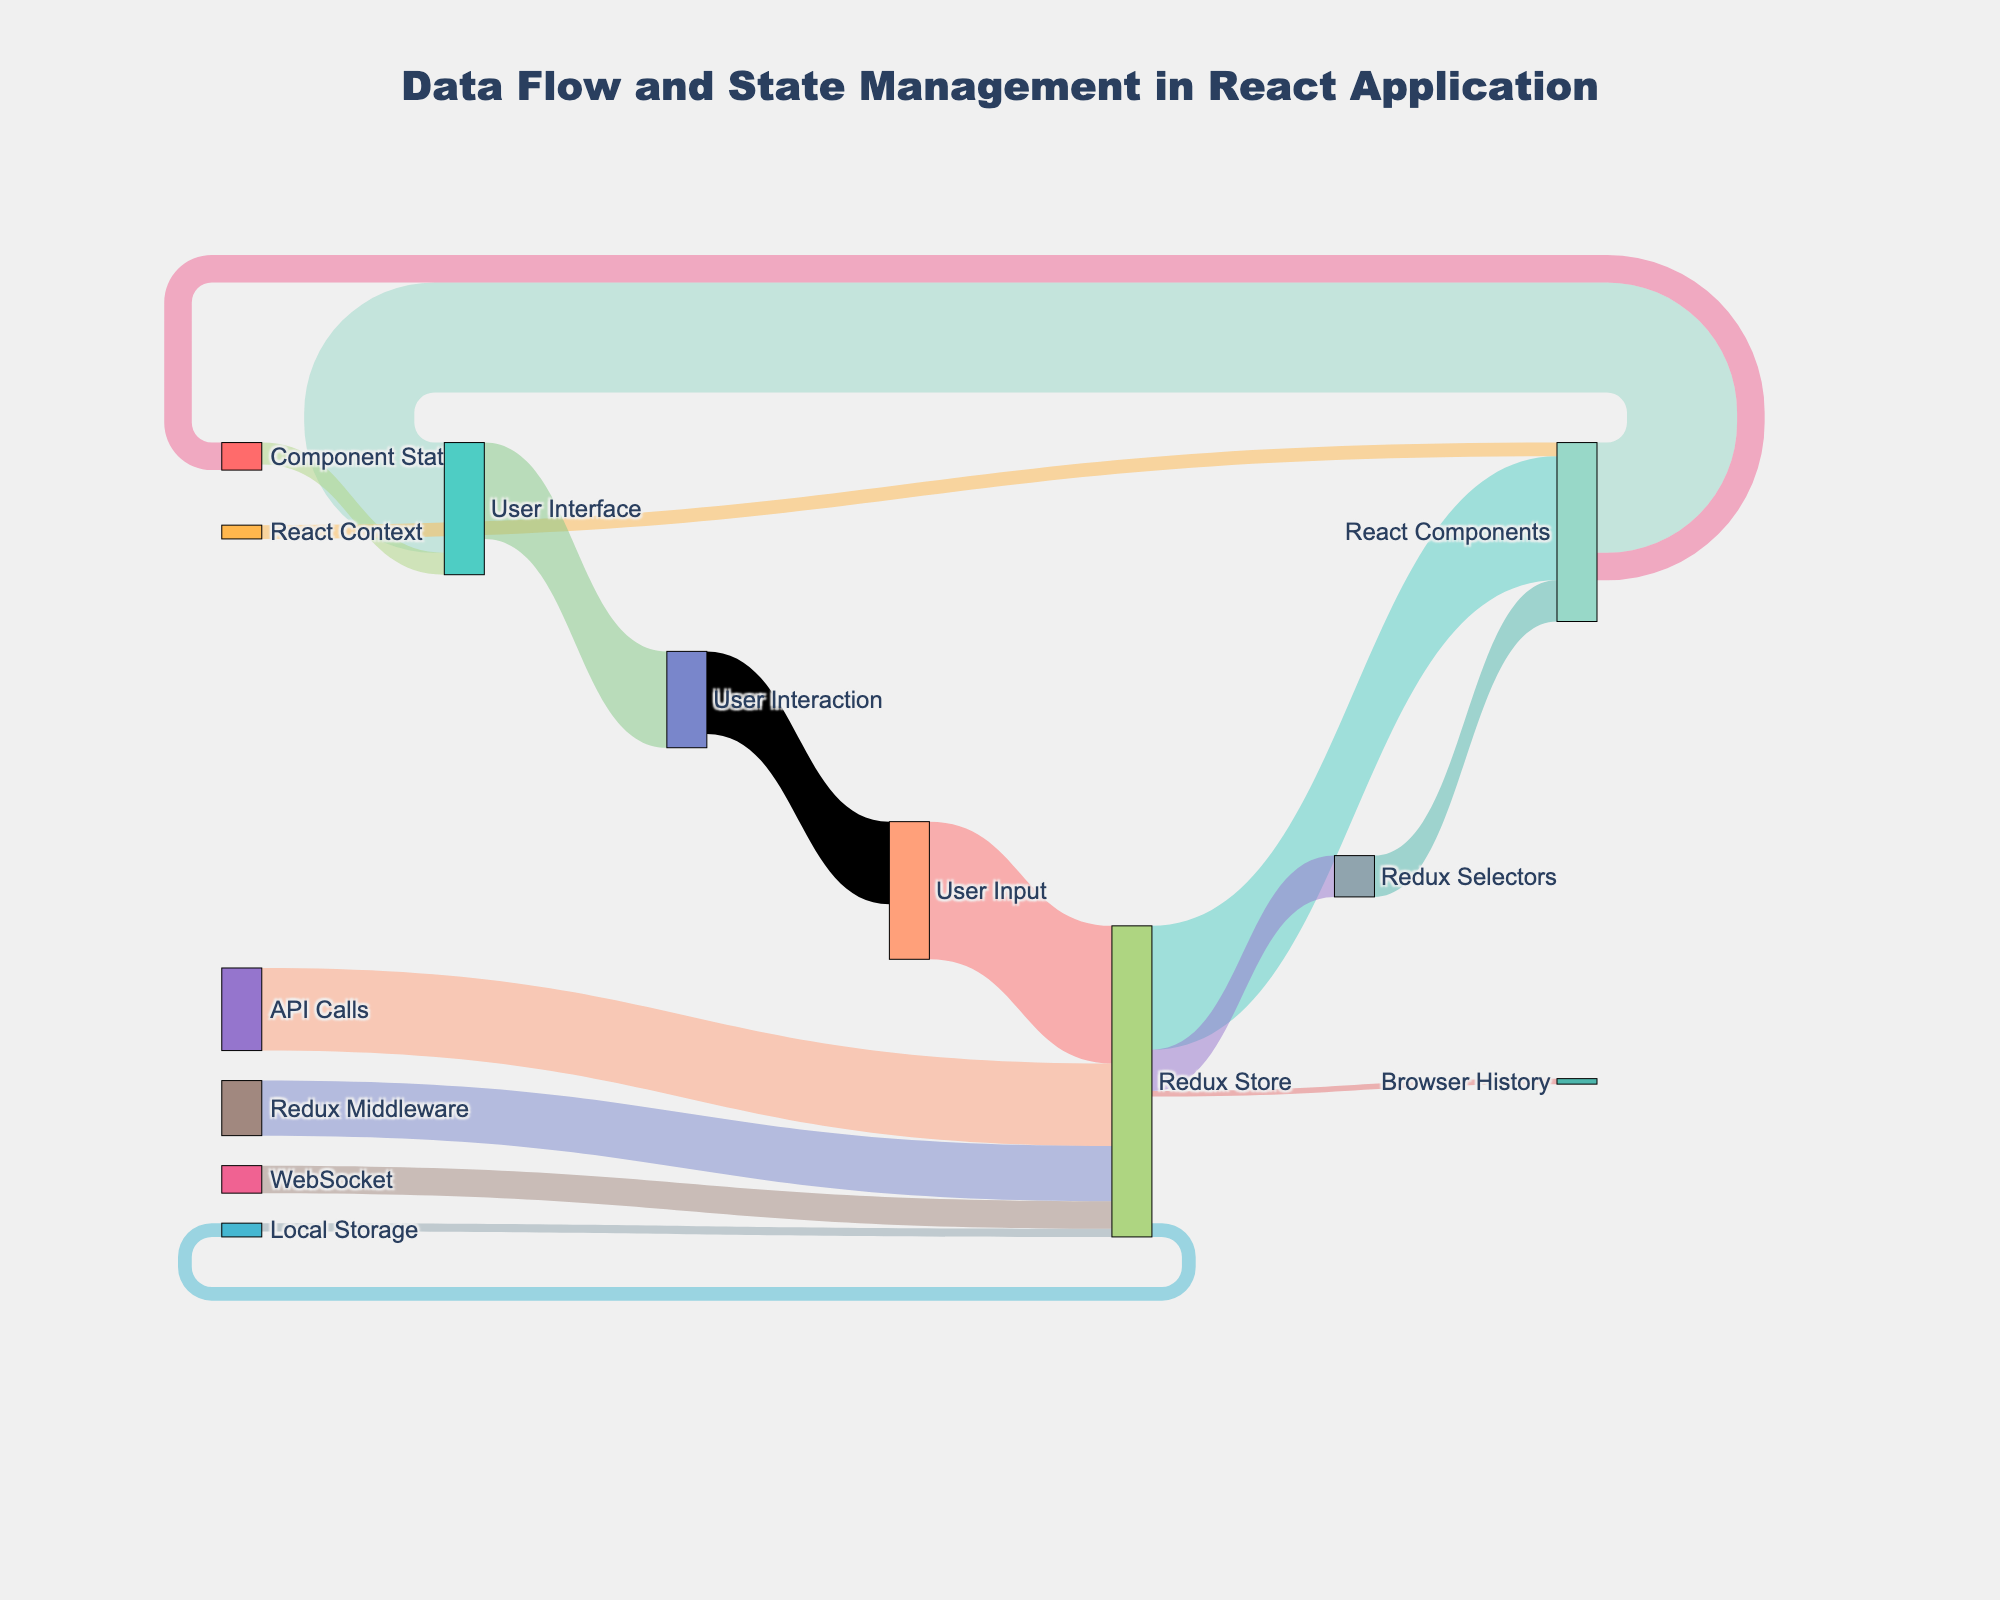What is the title of the diagram? The title is displayed at the top of the diagram and gives an overview of what the Sankey diagram represents.
Answer: Data Flow and State Management in React Application Which source node has the highest value flowing into the Redux Store? Look at all the connections flowing into the Redux Store. Identify the connection with the highest value.
Answer: User Input What is the combined value of data flowing from the Redux Store to other nodes? Sum up all the values flowing out from the Redux Store to other nodes: 45 (React Components) + 5 (Local Storage) + 15 (Redux Selectors) + 2 (Browser History).
Answer: 67 Which two components have direct data flow between them with the highest value, and what is that value? Identify the pair of components connected directly with the highest value by examining the diagram.
Answer: User Input and Redux Store How many unique nodes are there in the Sankey diagram? Count all the unique labels in the nodes section of the diagram.
Answer: 14 What is the value of data flowing between React Components and User Interface? Find the link between React Components and User Interface and note its value.
Answer: 40 What is the sum of values flowing into the User Interface? Add the values flowing into the User Interface: 40 (React Components) + 8 (Component State).
Answer: 48 Which has a higher value, data going from React Components to Component State or data going from Component State to User Interface? Compare the values of these two connections and determine the higher value.
Answer: React Components to Component State What is the total value of data flowing from any source to the Redux Store? Sum all the values flowing into the Redux Store: 50 (User Input) + 30 (API Calls) + 20 (Redux Middleware) + 10 (WebSocket) + 3 (Local Storage).
Answer: 113 How much data flows from User Interaction back to User Input? Look at the link from User Interaction to User Input and note its value.
Answer: 30 